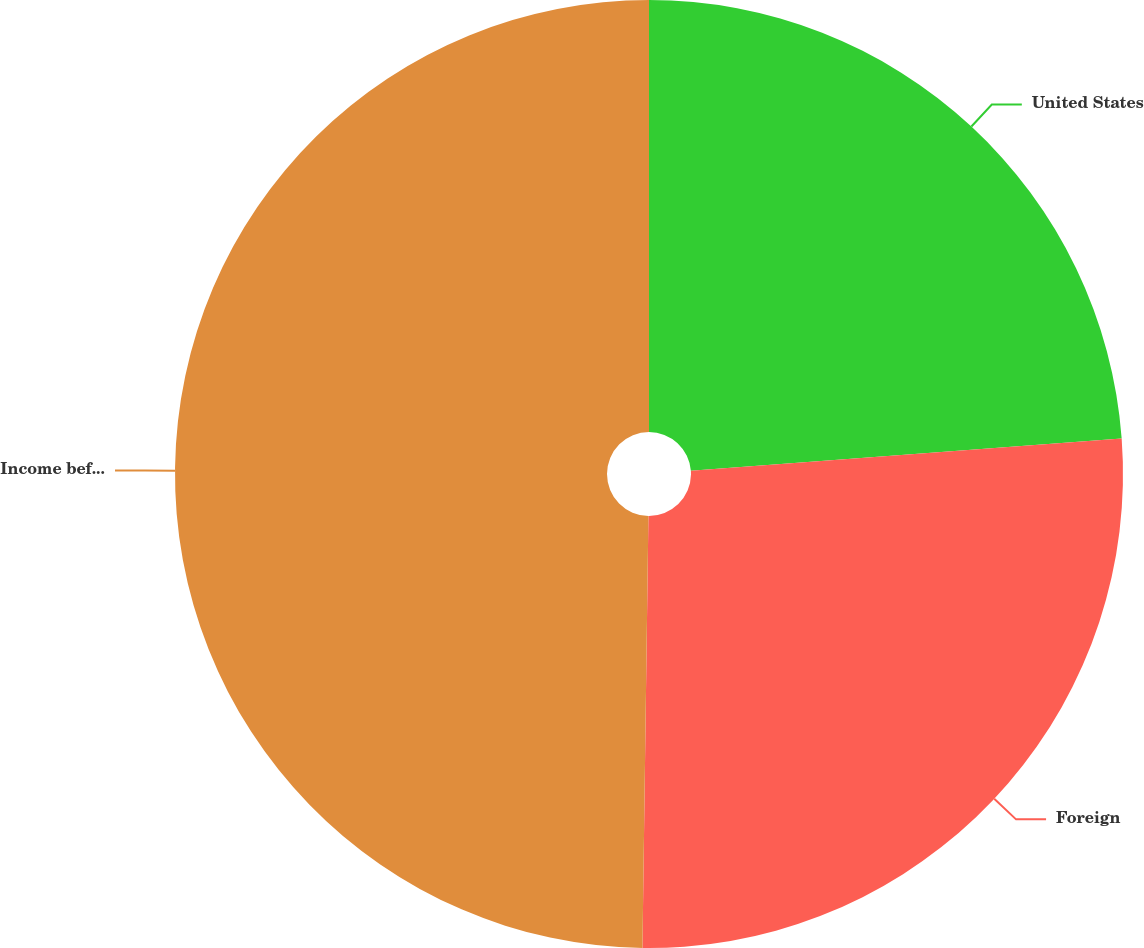<chart> <loc_0><loc_0><loc_500><loc_500><pie_chart><fcel>United States<fcel>Foreign<fcel>Income before income taxes<nl><fcel>23.81%<fcel>26.41%<fcel>49.78%<nl></chart> 